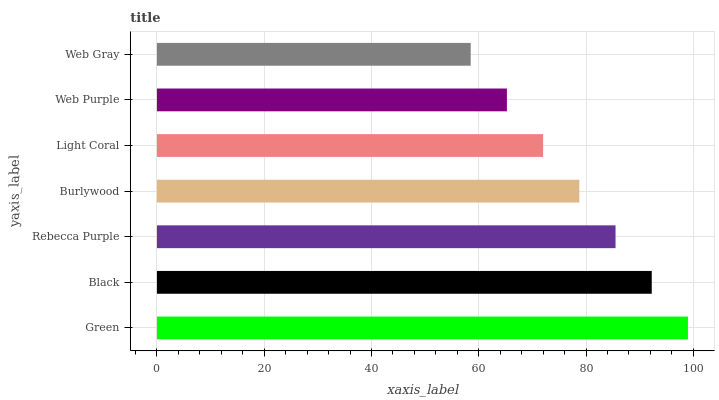Is Web Gray the minimum?
Answer yes or no. Yes. Is Green the maximum?
Answer yes or no. Yes. Is Black the minimum?
Answer yes or no. No. Is Black the maximum?
Answer yes or no. No. Is Green greater than Black?
Answer yes or no. Yes. Is Black less than Green?
Answer yes or no. Yes. Is Black greater than Green?
Answer yes or no. No. Is Green less than Black?
Answer yes or no. No. Is Burlywood the high median?
Answer yes or no. Yes. Is Burlywood the low median?
Answer yes or no. Yes. Is Green the high median?
Answer yes or no. No. Is Light Coral the low median?
Answer yes or no. No. 